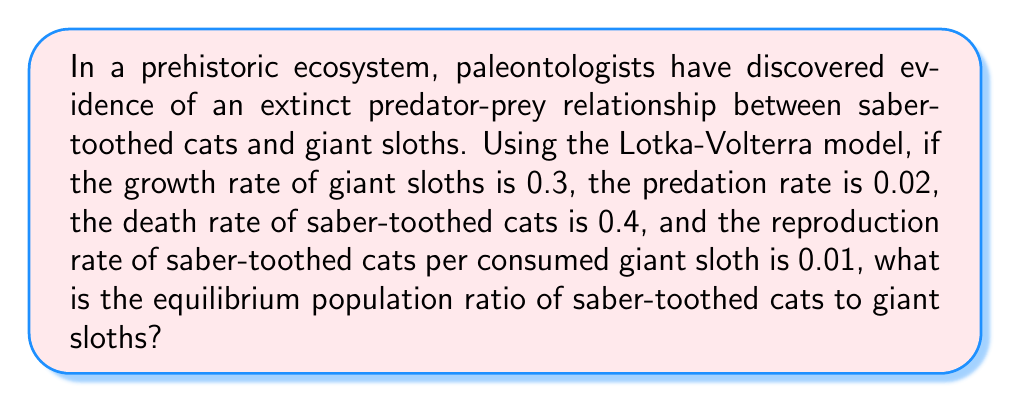Solve this math problem. Let's approach this step-by-step using the Lotka-Volterra model:

1) The Lotka-Volterra equations are:

   $$\frac{dx}{dt} = ax - bxy$$
   $$\frac{dy}{dt} = -cy + dxy$$

   Where x is the prey population (giant sloths), y is the predator population (saber-toothed cats), and a, b, c, and d are positive constants.

2) In this case:
   a = 0.3 (growth rate of giant sloths)
   b = 0.02 (predation rate)
   c = 0.4 (death rate of saber-toothed cats)
   d = 0.01 (reproduction rate of saber-toothed cats per consumed giant sloth)

3) At equilibrium, both equations equal zero:

   $$0 = ax - bxy$$
   $$0 = -cy + dxy$$

4) From the first equation:
   $$ax = bxy$$
   $$x = \frac{bxy}{a}$$

5) From the second equation:
   $$cy = dxy$$
   $$y = \frac{dx}{c}$$

6) The equilibrium ratio of predators to prey (y/x) is:

   $$\frac{y}{x} = \frac{dx/c}{x} = \frac{d}{c} = \frac{0.01}{0.4} = 0.025$$

7) To simplify this fraction:
   $$0.025 = \frac{1}{40}$$

Therefore, the equilibrium population ratio of saber-toothed cats to giant sloths is 1:40.
Answer: 1:40 